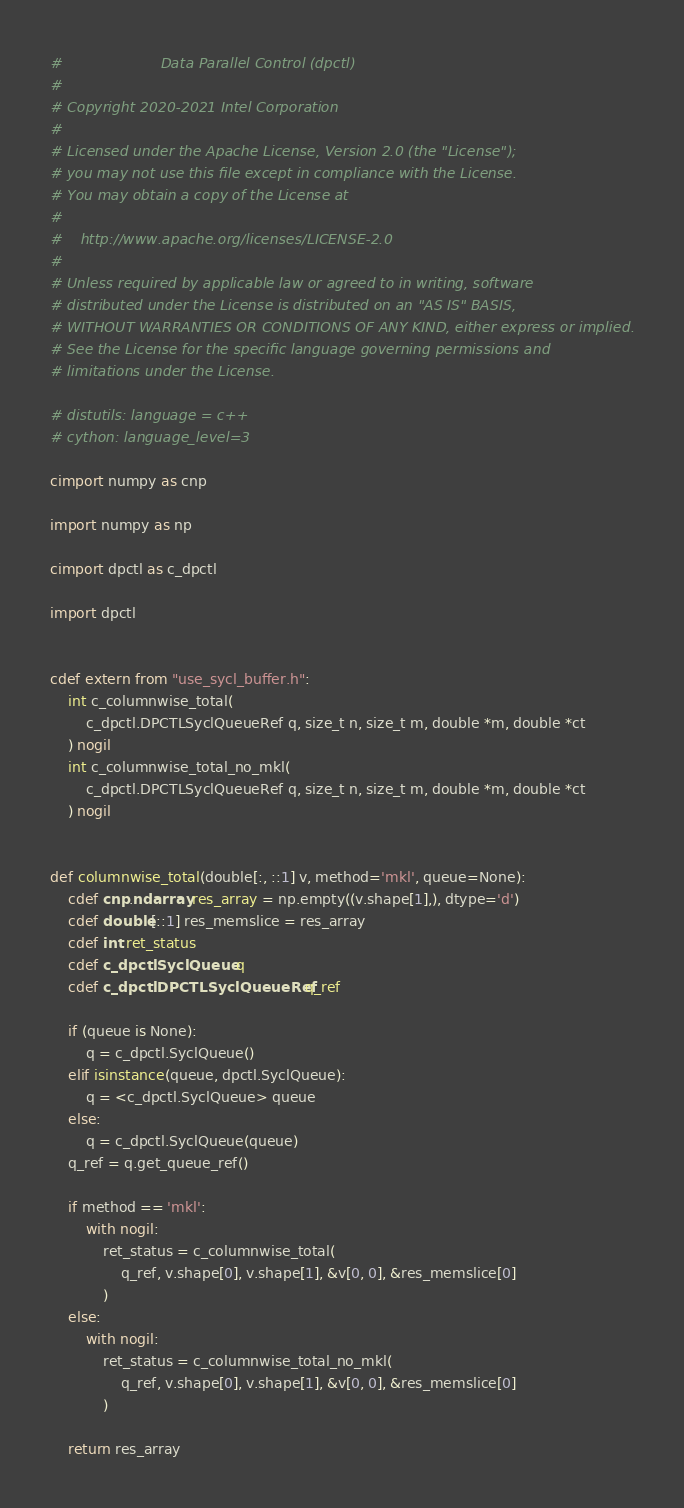Convert code to text. <code><loc_0><loc_0><loc_500><loc_500><_Cython_>#                      Data Parallel Control (dpctl)
#
# Copyright 2020-2021 Intel Corporation
#
# Licensed under the Apache License, Version 2.0 (the "License");
# you may not use this file except in compliance with the License.
# You may obtain a copy of the License at
#
#    http://www.apache.org/licenses/LICENSE-2.0
#
# Unless required by applicable law or agreed to in writing, software
# distributed under the License is distributed on an "AS IS" BASIS,
# WITHOUT WARRANTIES OR CONDITIONS OF ANY KIND, either express or implied.
# See the License for the specific language governing permissions and
# limitations under the License.

# distutils: language = c++
# cython: language_level=3

cimport numpy as cnp

import numpy as np

cimport dpctl as c_dpctl

import dpctl


cdef extern from "use_sycl_buffer.h":
    int c_columnwise_total(
        c_dpctl.DPCTLSyclQueueRef q, size_t n, size_t m, double *m, double *ct
    ) nogil
    int c_columnwise_total_no_mkl(
        c_dpctl.DPCTLSyclQueueRef q, size_t n, size_t m, double *m, double *ct
    ) nogil


def columnwise_total(double[:, ::1] v, method='mkl', queue=None):
    cdef cnp.ndarray res_array = np.empty((v.shape[1],), dtype='d')
    cdef double[::1] res_memslice = res_array
    cdef int ret_status
    cdef c_dpctl.SyclQueue q
    cdef c_dpctl.DPCTLSyclQueueRef q_ref

    if (queue is None):
        q = c_dpctl.SyclQueue()
    elif isinstance(queue, dpctl.SyclQueue):
        q = <c_dpctl.SyclQueue> queue
    else:
        q = c_dpctl.SyclQueue(queue)
    q_ref = q.get_queue_ref()

    if method == 'mkl':
        with nogil:
            ret_status = c_columnwise_total(
                q_ref, v.shape[0], v.shape[1], &v[0, 0], &res_memslice[0]
            )
    else:
        with nogil:
            ret_status = c_columnwise_total_no_mkl(
                q_ref, v.shape[0], v.shape[1], &v[0, 0], &res_memslice[0]
            )

    return res_array
</code> 